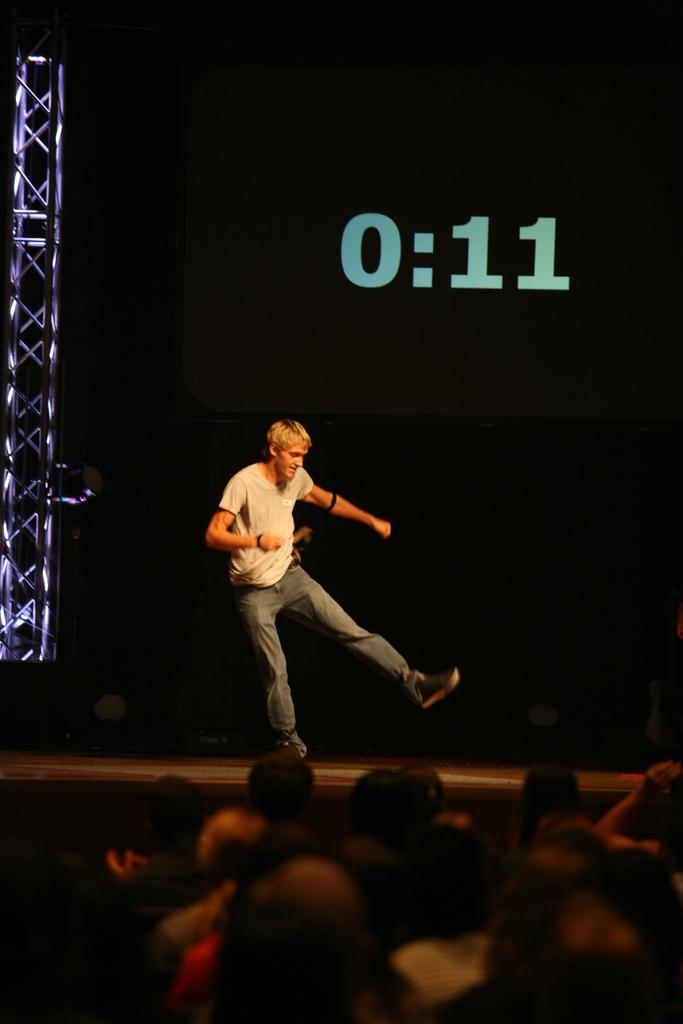Who is the main subject in the image? There is a man in the center of the image. What is happening at the bottom of the image? There is a crowd at the bottom of the image. What can be seen in the background of the image? There is a screen and a pillar in the background of the image. What is the source of illumination in the image? There is a light visible in the image. What riddle is the man trying to solve in the image? There is no riddle present in the image; it simply shows a man in the center of the image with a crowd, a screen, a pillar, and a light visible. 